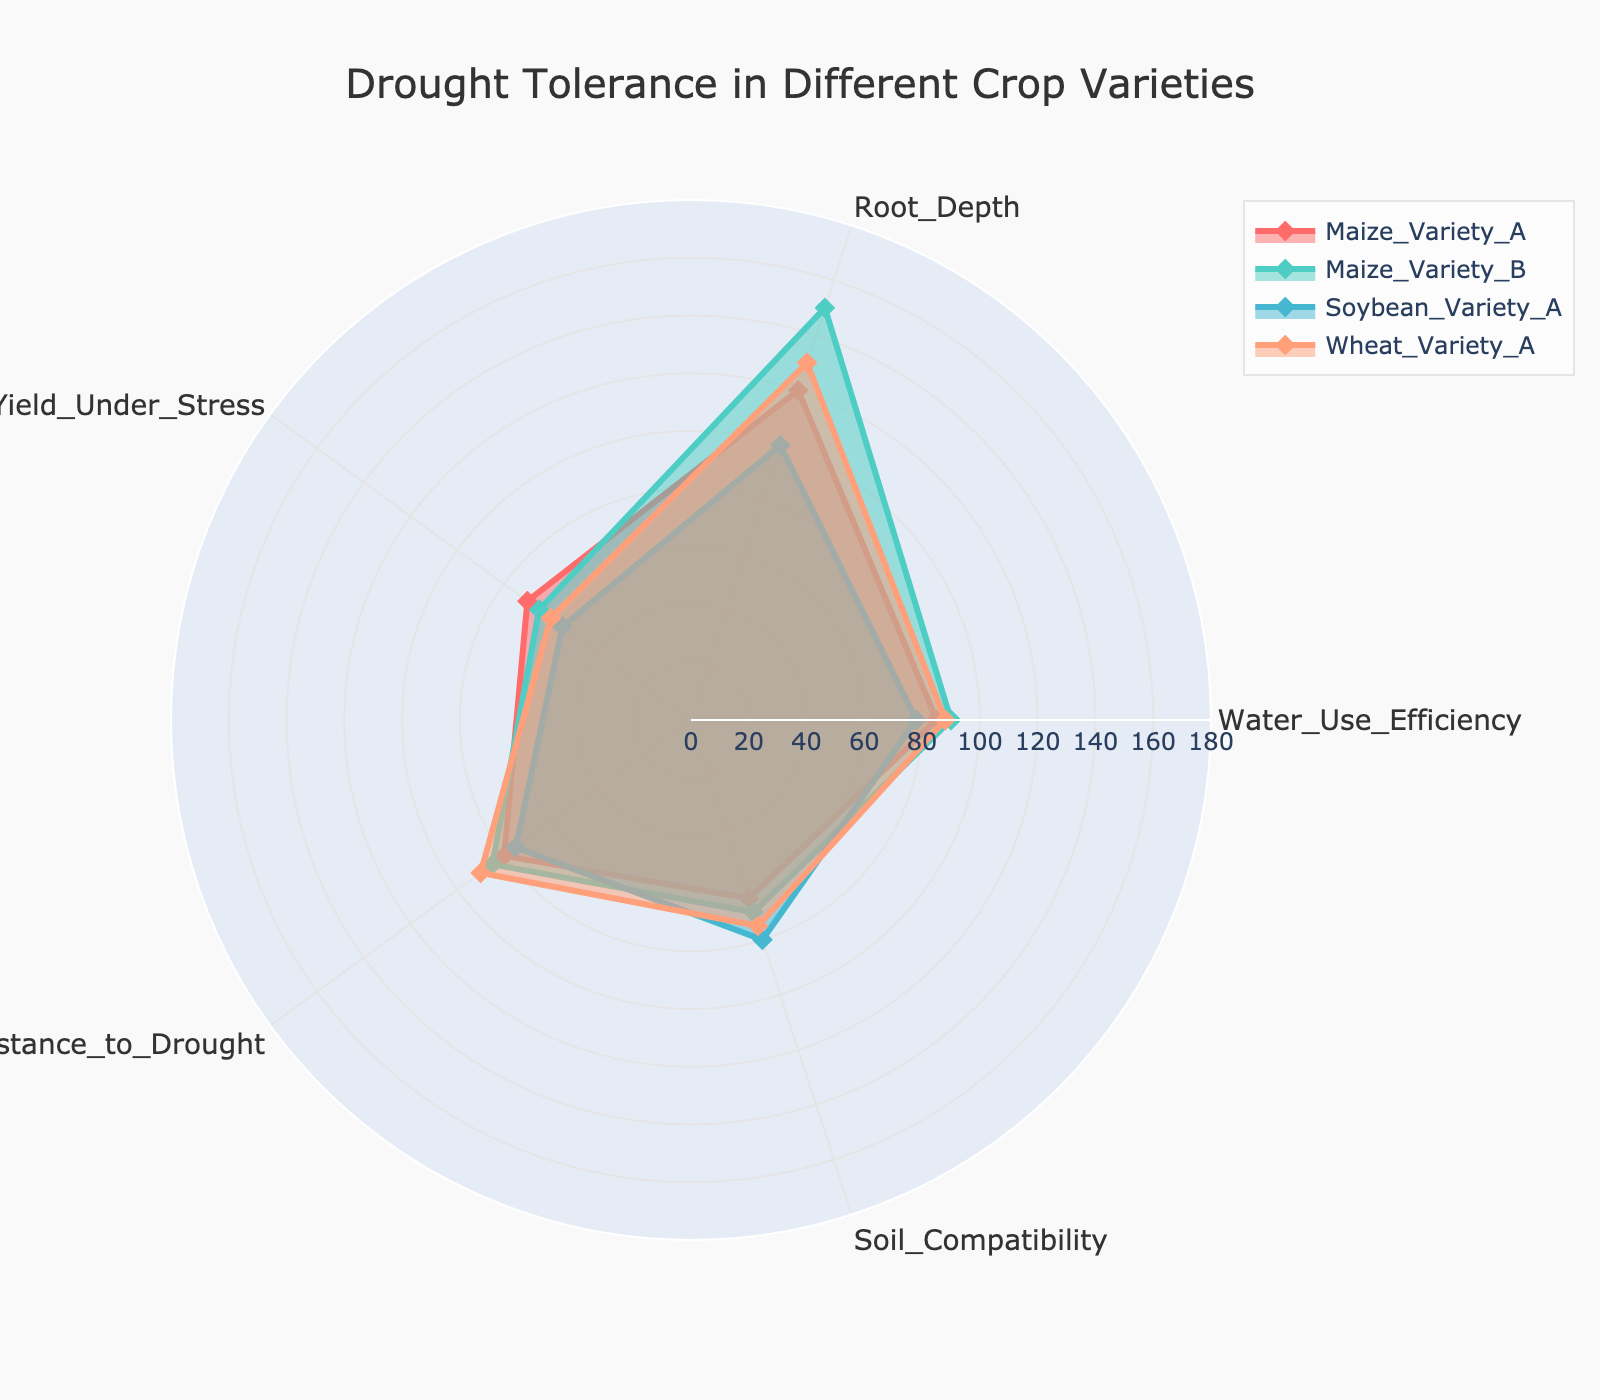What is the title of the radar chart? The chart title is displayed at the upper center of the radar chart area. It usually gives a quick overview of the chart’s purpose.
Answer: Drought Tolerance in Different Crop Varieties Which variety has the highest Root Depth? Root Depth for each variety is provided along the corresponding axis. Maize Variety B reaches the farthest along the Root Depth axis.
Answer: Maize Variety B What is the average Water Use Efficiency across all varieties? Sum Water Use Efficiency values for all varieties (85 + 90 + 78 + 88) and divide by the number of varieties (4). The calculation is (85 + 90 + 78 + 88) / 4 = 341 / 4 = 85.25
Answer: 85.25 Which variety shows the least compatibility with soil? Soil Compatibility axis indicates the values. Maize Variety A has the lowest value on this axis.
Answer: Maize Variety A Compare the Resistance to Drought between Maize Variety A and Wheat Variety A. Which one is higher? Check the Resistance to Drought axis for both varieties. Wheat Variety A has a higher value (90) compared to Maize Variety A (80).
Answer: Wheat Variety A By how much does the Root Depth of Wheat Variety A exceed that of Soybean Variety A? Subtract Root Depth of Soybean Variety A (100) from Wheat Variety A (130). The difference is 130 - 100 = 30.
Answer: 30 Which category shows the smallest value for Soybean Variety A? Identify the lowest value on the radar chart for Soybean Variety A, comparing each axis. The smallest value is Yield Under Stress (55).
Answer: Yield Under Stress What is the range of values for Water Use Efficiency? The range is calculated by subtracting the minimum value (78 for Soybean Variety A) from the maximum value (90 for Maize Variety B). The range is 90 - 78 = 12.
Answer: 12 Which variety has the highest score in Yield Under Stress? Locate Yield Under Stress on the chart for all varieties, identifying the highest value. Maize Variety A has the highest score (70).
Answer: Maize Variety A For Root Depth, what's the average of the highest and lowest variety values? Find the highest (Maize Variety B, 150) and lowest (Soybean Variety A, 100) values for Root Depth and compute the average. The average is (150 + 100) / 2 = 125.
Answer: 125 